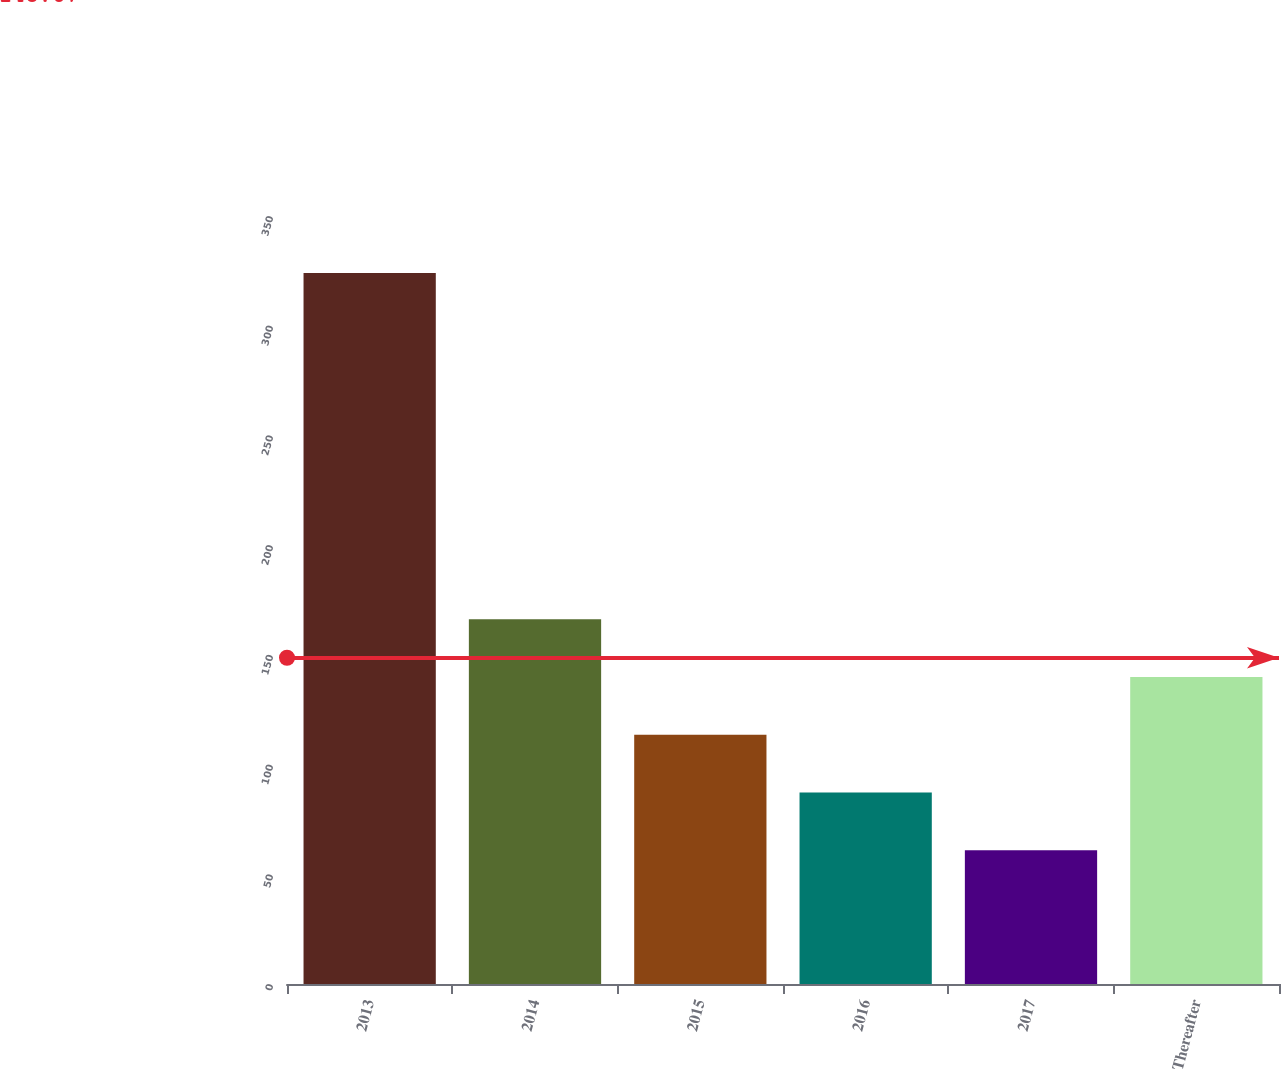Convert chart. <chart><loc_0><loc_0><loc_500><loc_500><bar_chart><fcel>2013<fcel>2014<fcel>2015<fcel>2016<fcel>2017<fcel>Thereafter<nl><fcel>324<fcel>166.2<fcel>113.6<fcel>87.3<fcel>61<fcel>139.9<nl></chart> 